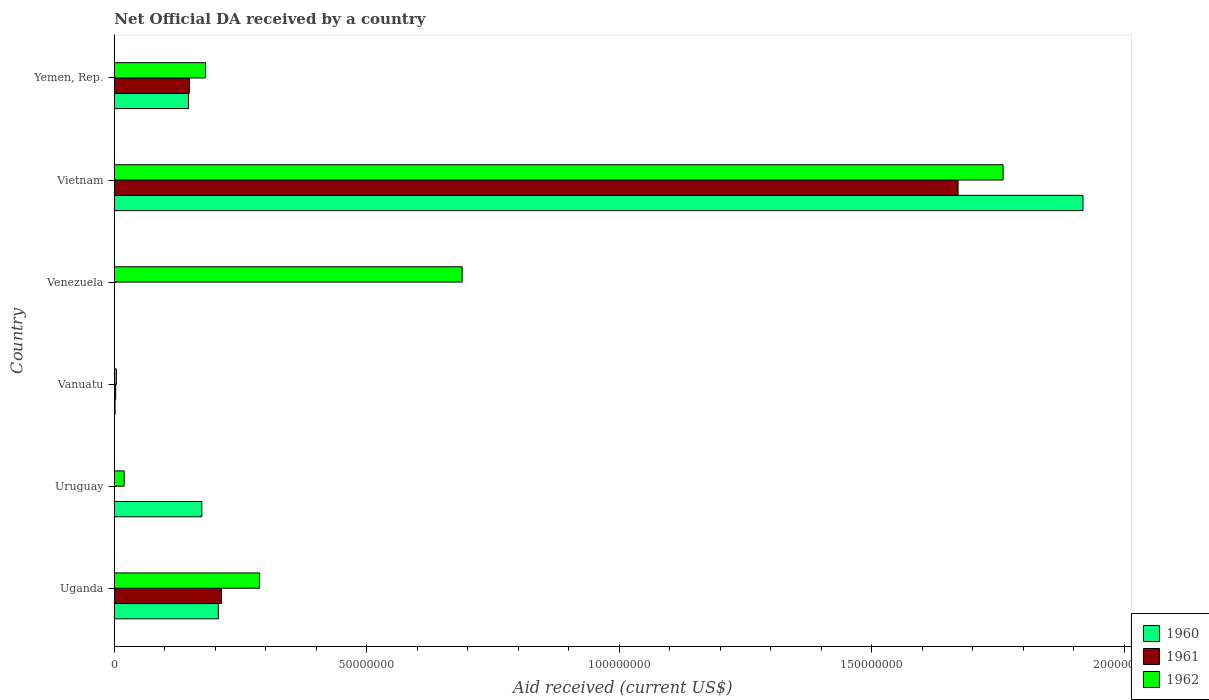How many different coloured bars are there?
Offer a very short reply. 3. Are the number of bars per tick equal to the number of legend labels?
Your answer should be very brief. No. Are the number of bars on each tick of the Y-axis equal?
Ensure brevity in your answer.  No. How many bars are there on the 1st tick from the bottom?
Your response must be concise. 3. What is the label of the 3rd group of bars from the top?
Ensure brevity in your answer.  Venezuela. In how many cases, is the number of bars for a given country not equal to the number of legend labels?
Make the answer very short. 2. What is the net official development assistance aid received in 1961 in Vietnam?
Provide a succinct answer. 1.67e+08. Across all countries, what is the maximum net official development assistance aid received in 1960?
Provide a short and direct response. 1.92e+08. In which country was the net official development assistance aid received in 1961 maximum?
Keep it short and to the point. Vietnam. What is the total net official development assistance aid received in 1962 in the graph?
Keep it short and to the point. 2.94e+08. What is the difference between the net official development assistance aid received in 1960 in Uganda and that in Vanuatu?
Provide a short and direct response. 2.04e+07. What is the difference between the net official development assistance aid received in 1962 in Uruguay and the net official development assistance aid received in 1961 in Vanuatu?
Offer a very short reply. 1.67e+06. What is the average net official development assistance aid received in 1962 per country?
Give a very brief answer. 4.90e+07. In how many countries, is the net official development assistance aid received in 1960 greater than 190000000 US$?
Your answer should be compact. 1. What is the ratio of the net official development assistance aid received in 1962 in Vietnam to that in Yemen, Rep.?
Offer a very short reply. 9.74. Is the net official development assistance aid received in 1961 in Uganda less than that in Yemen, Rep.?
Give a very brief answer. No. Is the difference between the net official development assistance aid received in 1960 in Uganda and Vanuatu greater than the difference between the net official development assistance aid received in 1961 in Uganda and Vanuatu?
Offer a very short reply. No. What is the difference between the highest and the second highest net official development assistance aid received in 1961?
Keep it short and to the point. 1.46e+08. What is the difference between the highest and the lowest net official development assistance aid received in 1961?
Offer a terse response. 1.67e+08. In how many countries, is the net official development assistance aid received in 1961 greater than the average net official development assistance aid received in 1961 taken over all countries?
Provide a succinct answer. 1. How many bars are there?
Ensure brevity in your answer.  15. Does the graph contain any zero values?
Ensure brevity in your answer.  Yes. Does the graph contain grids?
Provide a succinct answer. No. Where does the legend appear in the graph?
Your answer should be compact. Bottom right. What is the title of the graph?
Offer a very short reply. Net Official DA received by a country. Does "1974" appear as one of the legend labels in the graph?
Give a very brief answer. No. What is the label or title of the X-axis?
Provide a succinct answer. Aid received (current US$). What is the label or title of the Y-axis?
Your answer should be very brief. Country. What is the Aid received (current US$) in 1960 in Uganda?
Your answer should be very brief. 2.06e+07. What is the Aid received (current US$) of 1961 in Uganda?
Provide a short and direct response. 2.12e+07. What is the Aid received (current US$) in 1962 in Uganda?
Offer a very short reply. 2.88e+07. What is the Aid received (current US$) of 1960 in Uruguay?
Your answer should be very brief. 1.73e+07. What is the Aid received (current US$) in 1962 in Uruguay?
Make the answer very short. 1.95e+06. What is the Aid received (current US$) in 1960 in Vanuatu?
Keep it short and to the point. 1.50e+05. What is the Aid received (current US$) of 1961 in Venezuela?
Your response must be concise. 0. What is the Aid received (current US$) of 1962 in Venezuela?
Give a very brief answer. 6.89e+07. What is the Aid received (current US$) of 1960 in Vietnam?
Your response must be concise. 1.92e+08. What is the Aid received (current US$) in 1961 in Vietnam?
Give a very brief answer. 1.67e+08. What is the Aid received (current US$) of 1962 in Vietnam?
Make the answer very short. 1.76e+08. What is the Aid received (current US$) in 1960 in Yemen, Rep.?
Make the answer very short. 1.47e+07. What is the Aid received (current US$) of 1961 in Yemen, Rep.?
Provide a short and direct response. 1.49e+07. What is the Aid received (current US$) in 1962 in Yemen, Rep.?
Provide a short and direct response. 1.81e+07. Across all countries, what is the maximum Aid received (current US$) of 1960?
Give a very brief answer. 1.92e+08. Across all countries, what is the maximum Aid received (current US$) in 1961?
Your answer should be very brief. 1.67e+08. Across all countries, what is the maximum Aid received (current US$) in 1962?
Ensure brevity in your answer.  1.76e+08. Across all countries, what is the minimum Aid received (current US$) of 1960?
Your response must be concise. 0. Across all countries, what is the minimum Aid received (current US$) in 1961?
Provide a succinct answer. 0. Across all countries, what is the minimum Aid received (current US$) of 1962?
Give a very brief answer. 4.10e+05. What is the total Aid received (current US$) in 1960 in the graph?
Make the answer very short. 2.45e+08. What is the total Aid received (current US$) of 1961 in the graph?
Ensure brevity in your answer.  2.04e+08. What is the total Aid received (current US$) in 1962 in the graph?
Your answer should be compact. 2.94e+08. What is the difference between the Aid received (current US$) of 1960 in Uganda and that in Uruguay?
Ensure brevity in your answer.  3.27e+06. What is the difference between the Aid received (current US$) of 1962 in Uganda and that in Uruguay?
Provide a short and direct response. 2.68e+07. What is the difference between the Aid received (current US$) in 1960 in Uganda and that in Vanuatu?
Provide a short and direct response. 2.04e+07. What is the difference between the Aid received (current US$) of 1961 in Uganda and that in Vanuatu?
Provide a succinct answer. 2.10e+07. What is the difference between the Aid received (current US$) of 1962 in Uganda and that in Vanuatu?
Offer a terse response. 2.84e+07. What is the difference between the Aid received (current US$) in 1962 in Uganda and that in Venezuela?
Give a very brief answer. -4.01e+07. What is the difference between the Aid received (current US$) in 1960 in Uganda and that in Vietnam?
Give a very brief answer. -1.71e+08. What is the difference between the Aid received (current US$) of 1961 in Uganda and that in Vietnam?
Your answer should be compact. -1.46e+08. What is the difference between the Aid received (current US$) of 1962 in Uganda and that in Vietnam?
Give a very brief answer. -1.47e+08. What is the difference between the Aid received (current US$) of 1960 in Uganda and that in Yemen, Rep.?
Make the answer very short. 5.91e+06. What is the difference between the Aid received (current US$) of 1961 in Uganda and that in Yemen, Rep.?
Your answer should be very brief. 6.35e+06. What is the difference between the Aid received (current US$) of 1962 in Uganda and that in Yemen, Rep.?
Make the answer very short. 1.07e+07. What is the difference between the Aid received (current US$) of 1960 in Uruguay and that in Vanuatu?
Your answer should be compact. 1.72e+07. What is the difference between the Aid received (current US$) of 1962 in Uruguay and that in Vanuatu?
Provide a succinct answer. 1.54e+06. What is the difference between the Aid received (current US$) in 1962 in Uruguay and that in Venezuela?
Ensure brevity in your answer.  -6.69e+07. What is the difference between the Aid received (current US$) of 1960 in Uruguay and that in Vietnam?
Ensure brevity in your answer.  -1.75e+08. What is the difference between the Aid received (current US$) in 1962 in Uruguay and that in Vietnam?
Provide a short and direct response. -1.74e+08. What is the difference between the Aid received (current US$) of 1960 in Uruguay and that in Yemen, Rep.?
Your answer should be very brief. 2.64e+06. What is the difference between the Aid received (current US$) in 1962 in Uruguay and that in Yemen, Rep.?
Your answer should be compact. -1.61e+07. What is the difference between the Aid received (current US$) in 1962 in Vanuatu and that in Venezuela?
Ensure brevity in your answer.  -6.85e+07. What is the difference between the Aid received (current US$) in 1960 in Vanuatu and that in Vietnam?
Your answer should be very brief. -1.92e+08. What is the difference between the Aid received (current US$) in 1961 in Vanuatu and that in Vietnam?
Your response must be concise. -1.67e+08. What is the difference between the Aid received (current US$) of 1962 in Vanuatu and that in Vietnam?
Provide a succinct answer. -1.76e+08. What is the difference between the Aid received (current US$) of 1960 in Vanuatu and that in Yemen, Rep.?
Provide a short and direct response. -1.45e+07. What is the difference between the Aid received (current US$) of 1961 in Vanuatu and that in Yemen, Rep.?
Provide a succinct answer. -1.46e+07. What is the difference between the Aid received (current US$) in 1962 in Vanuatu and that in Yemen, Rep.?
Offer a terse response. -1.77e+07. What is the difference between the Aid received (current US$) of 1962 in Venezuela and that in Vietnam?
Ensure brevity in your answer.  -1.07e+08. What is the difference between the Aid received (current US$) of 1962 in Venezuela and that in Yemen, Rep.?
Offer a terse response. 5.08e+07. What is the difference between the Aid received (current US$) in 1960 in Vietnam and that in Yemen, Rep.?
Offer a terse response. 1.77e+08. What is the difference between the Aid received (current US$) of 1961 in Vietnam and that in Yemen, Rep.?
Keep it short and to the point. 1.52e+08. What is the difference between the Aid received (current US$) in 1962 in Vietnam and that in Yemen, Rep.?
Your answer should be compact. 1.58e+08. What is the difference between the Aid received (current US$) of 1960 in Uganda and the Aid received (current US$) of 1962 in Uruguay?
Your response must be concise. 1.86e+07. What is the difference between the Aid received (current US$) of 1961 in Uganda and the Aid received (current US$) of 1962 in Uruguay?
Ensure brevity in your answer.  1.93e+07. What is the difference between the Aid received (current US$) of 1960 in Uganda and the Aid received (current US$) of 1961 in Vanuatu?
Provide a short and direct response. 2.03e+07. What is the difference between the Aid received (current US$) of 1960 in Uganda and the Aid received (current US$) of 1962 in Vanuatu?
Your answer should be very brief. 2.02e+07. What is the difference between the Aid received (current US$) in 1961 in Uganda and the Aid received (current US$) in 1962 in Vanuatu?
Keep it short and to the point. 2.08e+07. What is the difference between the Aid received (current US$) in 1960 in Uganda and the Aid received (current US$) in 1962 in Venezuela?
Make the answer very short. -4.83e+07. What is the difference between the Aid received (current US$) of 1961 in Uganda and the Aid received (current US$) of 1962 in Venezuela?
Offer a terse response. -4.77e+07. What is the difference between the Aid received (current US$) in 1960 in Uganda and the Aid received (current US$) in 1961 in Vietnam?
Offer a terse response. -1.47e+08. What is the difference between the Aid received (current US$) in 1960 in Uganda and the Aid received (current US$) in 1962 in Vietnam?
Your response must be concise. -1.55e+08. What is the difference between the Aid received (current US$) in 1961 in Uganda and the Aid received (current US$) in 1962 in Vietnam?
Ensure brevity in your answer.  -1.55e+08. What is the difference between the Aid received (current US$) of 1960 in Uganda and the Aid received (current US$) of 1961 in Yemen, Rep.?
Make the answer very short. 5.72e+06. What is the difference between the Aid received (current US$) of 1960 in Uganda and the Aid received (current US$) of 1962 in Yemen, Rep.?
Offer a very short reply. 2.52e+06. What is the difference between the Aid received (current US$) of 1961 in Uganda and the Aid received (current US$) of 1962 in Yemen, Rep.?
Provide a succinct answer. 3.15e+06. What is the difference between the Aid received (current US$) of 1960 in Uruguay and the Aid received (current US$) of 1961 in Vanuatu?
Give a very brief answer. 1.70e+07. What is the difference between the Aid received (current US$) in 1960 in Uruguay and the Aid received (current US$) in 1962 in Vanuatu?
Your answer should be very brief. 1.69e+07. What is the difference between the Aid received (current US$) of 1960 in Uruguay and the Aid received (current US$) of 1962 in Venezuela?
Your response must be concise. -5.16e+07. What is the difference between the Aid received (current US$) of 1960 in Uruguay and the Aid received (current US$) of 1961 in Vietnam?
Offer a very short reply. -1.50e+08. What is the difference between the Aid received (current US$) of 1960 in Uruguay and the Aid received (current US$) of 1962 in Vietnam?
Your answer should be very brief. -1.59e+08. What is the difference between the Aid received (current US$) in 1960 in Uruguay and the Aid received (current US$) in 1961 in Yemen, Rep.?
Offer a terse response. 2.45e+06. What is the difference between the Aid received (current US$) of 1960 in Uruguay and the Aid received (current US$) of 1962 in Yemen, Rep.?
Your answer should be compact. -7.50e+05. What is the difference between the Aid received (current US$) of 1960 in Vanuatu and the Aid received (current US$) of 1962 in Venezuela?
Provide a succinct answer. -6.87e+07. What is the difference between the Aid received (current US$) of 1961 in Vanuatu and the Aid received (current US$) of 1962 in Venezuela?
Ensure brevity in your answer.  -6.86e+07. What is the difference between the Aid received (current US$) in 1960 in Vanuatu and the Aid received (current US$) in 1961 in Vietnam?
Ensure brevity in your answer.  -1.67e+08. What is the difference between the Aid received (current US$) in 1960 in Vanuatu and the Aid received (current US$) in 1962 in Vietnam?
Your answer should be compact. -1.76e+08. What is the difference between the Aid received (current US$) in 1961 in Vanuatu and the Aid received (current US$) in 1962 in Vietnam?
Give a very brief answer. -1.76e+08. What is the difference between the Aid received (current US$) in 1960 in Vanuatu and the Aid received (current US$) in 1961 in Yemen, Rep.?
Ensure brevity in your answer.  -1.47e+07. What is the difference between the Aid received (current US$) in 1960 in Vanuatu and the Aid received (current US$) in 1962 in Yemen, Rep.?
Your answer should be very brief. -1.79e+07. What is the difference between the Aid received (current US$) in 1961 in Vanuatu and the Aid received (current US$) in 1962 in Yemen, Rep.?
Offer a terse response. -1.78e+07. What is the difference between the Aid received (current US$) in 1960 in Vietnam and the Aid received (current US$) in 1961 in Yemen, Rep.?
Give a very brief answer. 1.77e+08. What is the difference between the Aid received (current US$) in 1960 in Vietnam and the Aid received (current US$) in 1962 in Yemen, Rep.?
Provide a succinct answer. 1.74e+08. What is the difference between the Aid received (current US$) in 1961 in Vietnam and the Aid received (current US$) in 1962 in Yemen, Rep.?
Your answer should be very brief. 1.49e+08. What is the average Aid received (current US$) in 1960 per country?
Provide a succinct answer. 4.08e+07. What is the average Aid received (current US$) in 1961 per country?
Keep it short and to the point. 3.39e+07. What is the average Aid received (current US$) of 1962 per country?
Provide a short and direct response. 4.90e+07. What is the difference between the Aid received (current US$) of 1960 and Aid received (current US$) of 1961 in Uganda?
Make the answer very short. -6.30e+05. What is the difference between the Aid received (current US$) of 1960 and Aid received (current US$) of 1962 in Uganda?
Make the answer very short. -8.17e+06. What is the difference between the Aid received (current US$) of 1961 and Aid received (current US$) of 1962 in Uganda?
Offer a terse response. -7.54e+06. What is the difference between the Aid received (current US$) in 1960 and Aid received (current US$) in 1962 in Uruguay?
Give a very brief answer. 1.54e+07. What is the difference between the Aid received (current US$) in 1960 and Aid received (current US$) in 1961 in Vietnam?
Make the answer very short. 2.47e+07. What is the difference between the Aid received (current US$) of 1960 and Aid received (current US$) of 1962 in Vietnam?
Ensure brevity in your answer.  1.58e+07. What is the difference between the Aid received (current US$) in 1961 and Aid received (current US$) in 1962 in Vietnam?
Give a very brief answer. -8.92e+06. What is the difference between the Aid received (current US$) in 1960 and Aid received (current US$) in 1962 in Yemen, Rep.?
Make the answer very short. -3.39e+06. What is the difference between the Aid received (current US$) of 1961 and Aid received (current US$) of 1962 in Yemen, Rep.?
Offer a terse response. -3.20e+06. What is the ratio of the Aid received (current US$) of 1960 in Uganda to that in Uruguay?
Provide a short and direct response. 1.19. What is the ratio of the Aid received (current US$) of 1962 in Uganda to that in Uruguay?
Give a very brief answer. 14.75. What is the ratio of the Aid received (current US$) in 1960 in Uganda to that in Vanuatu?
Make the answer very short. 137.33. What is the ratio of the Aid received (current US$) of 1961 in Uganda to that in Vanuatu?
Your answer should be very brief. 75.82. What is the ratio of the Aid received (current US$) of 1962 in Uganda to that in Vanuatu?
Your answer should be very brief. 70.17. What is the ratio of the Aid received (current US$) of 1962 in Uganda to that in Venezuela?
Your answer should be compact. 0.42. What is the ratio of the Aid received (current US$) in 1960 in Uganda to that in Vietnam?
Make the answer very short. 0.11. What is the ratio of the Aid received (current US$) of 1961 in Uganda to that in Vietnam?
Give a very brief answer. 0.13. What is the ratio of the Aid received (current US$) in 1962 in Uganda to that in Vietnam?
Your answer should be very brief. 0.16. What is the ratio of the Aid received (current US$) of 1960 in Uganda to that in Yemen, Rep.?
Your answer should be compact. 1.4. What is the ratio of the Aid received (current US$) of 1961 in Uganda to that in Yemen, Rep.?
Give a very brief answer. 1.43. What is the ratio of the Aid received (current US$) in 1962 in Uganda to that in Yemen, Rep.?
Your response must be concise. 1.59. What is the ratio of the Aid received (current US$) in 1960 in Uruguay to that in Vanuatu?
Provide a short and direct response. 115.53. What is the ratio of the Aid received (current US$) of 1962 in Uruguay to that in Vanuatu?
Offer a very short reply. 4.76. What is the ratio of the Aid received (current US$) of 1962 in Uruguay to that in Venezuela?
Provide a short and direct response. 0.03. What is the ratio of the Aid received (current US$) of 1960 in Uruguay to that in Vietnam?
Offer a very short reply. 0.09. What is the ratio of the Aid received (current US$) in 1962 in Uruguay to that in Vietnam?
Provide a succinct answer. 0.01. What is the ratio of the Aid received (current US$) of 1960 in Uruguay to that in Yemen, Rep.?
Your answer should be compact. 1.18. What is the ratio of the Aid received (current US$) of 1962 in Uruguay to that in Yemen, Rep.?
Your answer should be compact. 0.11. What is the ratio of the Aid received (current US$) of 1962 in Vanuatu to that in Venezuela?
Your answer should be very brief. 0.01. What is the ratio of the Aid received (current US$) in 1960 in Vanuatu to that in Vietnam?
Make the answer very short. 0. What is the ratio of the Aid received (current US$) in 1961 in Vanuatu to that in Vietnam?
Offer a very short reply. 0. What is the ratio of the Aid received (current US$) in 1962 in Vanuatu to that in Vietnam?
Your response must be concise. 0. What is the ratio of the Aid received (current US$) of 1960 in Vanuatu to that in Yemen, Rep.?
Provide a succinct answer. 0.01. What is the ratio of the Aid received (current US$) in 1961 in Vanuatu to that in Yemen, Rep.?
Your answer should be compact. 0.02. What is the ratio of the Aid received (current US$) in 1962 in Vanuatu to that in Yemen, Rep.?
Make the answer very short. 0.02. What is the ratio of the Aid received (current US$) of 1962 in Venezuela to that in Vietnam?
Give a very brief answer. 0.39. What is the ratio of the Aid received (current US$) in 1962 in Venezuela to that in Yemen, Rep.?
Make the answer very short. 3.81. What is the ratio of the Aid received (current US$) of 1960 in Vietnam to that in Yemen, Rep.?
Keep it short and to the point. 13.06. What is the ratio of the Aid received (current US$) in 1961 in Vietnam to that in Yemen, Rep.?
Keep it short and to the point. 11.23. What is the ratio of the Aid received (current US$) in 1962 in Vietnam to that in Yemen, Rep.?
Make the answer very short. 9.74. What is the difference between the highest and the second highest Aid received (current US$) of 1960?
Ensure brevity in your answer.  1.71e+08. What is the difference between the highest and the second highest Aid received (current US$) of 1961?
Offer a terse response. 1.46e+08. What is the difference between the highest and the second highest Aid received (current US$) of 1962?
Ensure brevity in your answer.  1.07e+08. What is the difference between the highest and the lowest Aid received (current US$) of 1960?
Make the answer very short. 1.92e+08. What is the difference between the highest and the lowest Aid received (current US$) in 1961?
Your answer should be very brief. 1.67e+08. What is the difference between the highest and the lowest Aid received (current US$) of 1962?
Provide a short and direct response. 1.76e+08. 